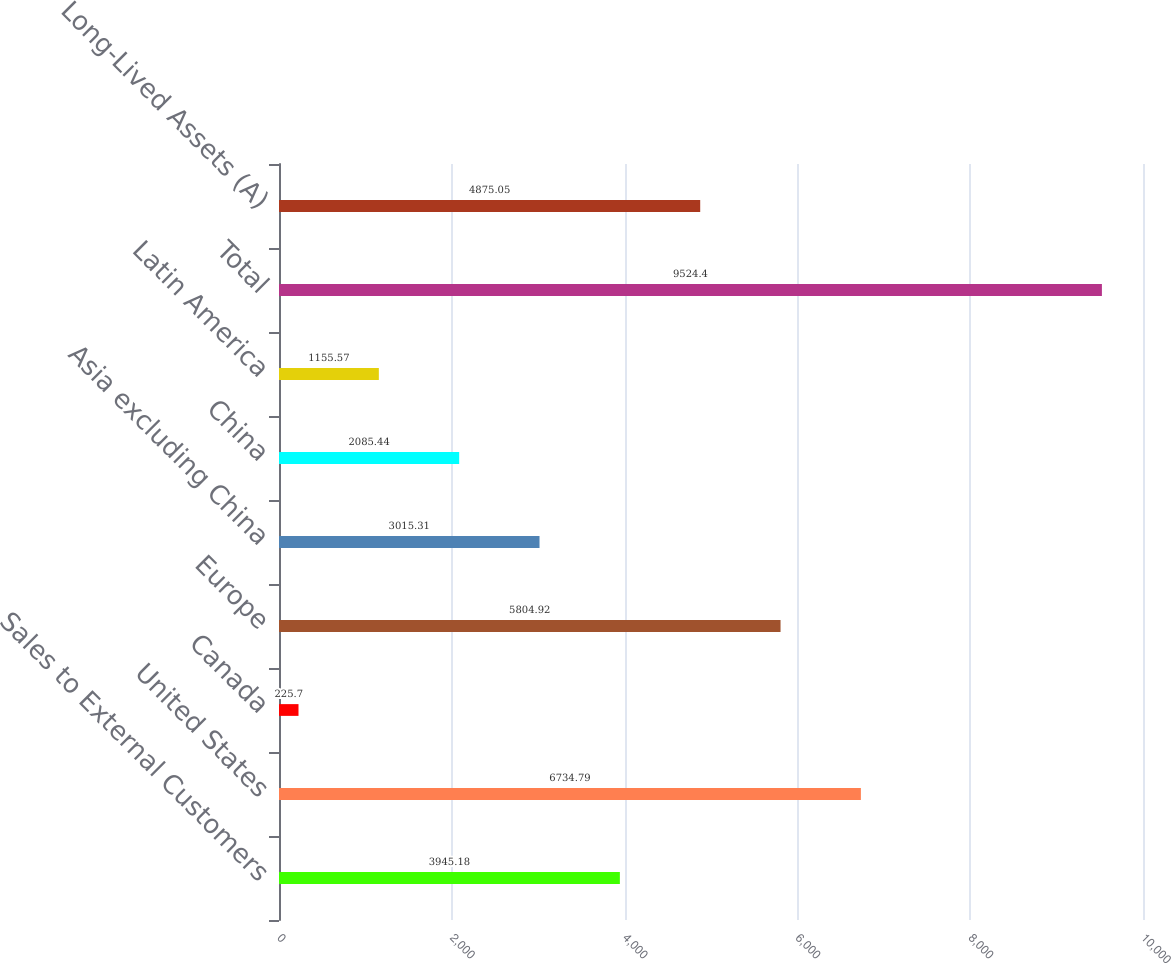Convert chart. <chart><loc_0><loc_0><loc_500><loc_500><bar_chart><fcel>Sales to External Customers<fcel>United States<fcel>Canada<fcel>Europe<fcel>Asia excluding China<fcel>China<fcel>Latin America<fcel>Total<fcel>Long-Lived Assets (A)<nl><fcel>3945.18<fcel>6734.79<fcel>225.7<fcel>5804.92<fcel>3015.31<fcel>2085.44<fcel>1155.57<fcel>9524.4<fcel>4875.05<nl></chart> 